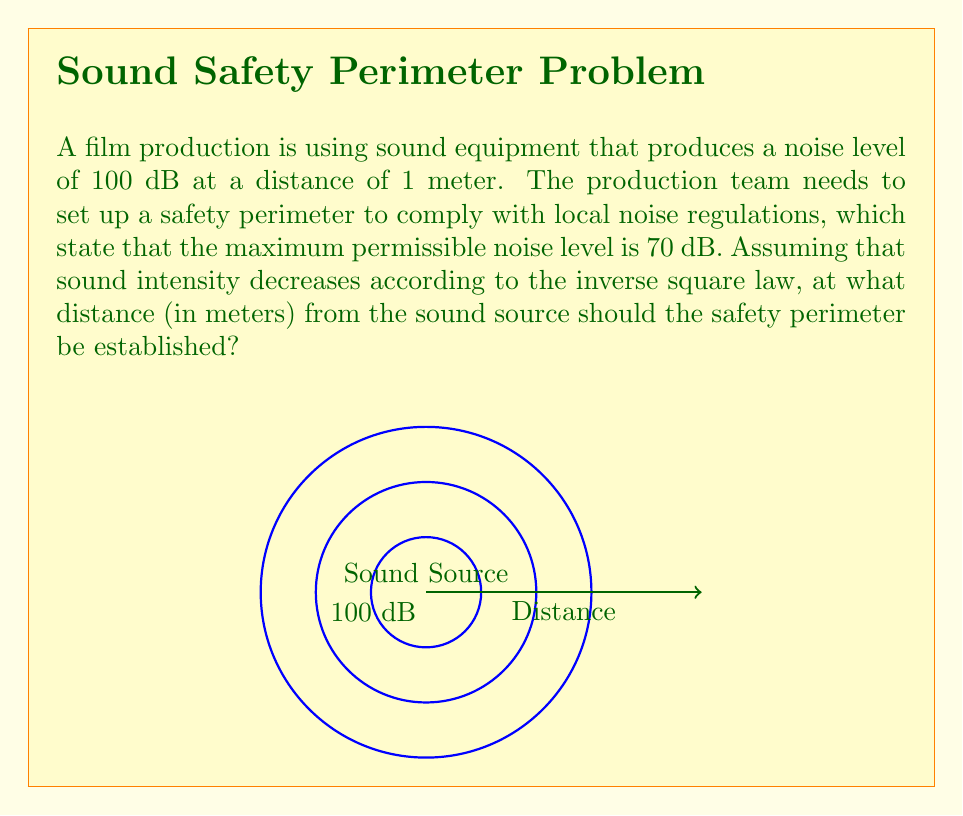Can you solve this math problem? To solve this problem, we'll use the inverse square law for sound intensity and the decibel scale. Let's break it down step-by-step:

1) The inverse square law states that sound intensity is inversely proportional to the square of the distance from the source. We can express this as:

   $$\frac{I_1}{I_2} = \frac{r_2^2}{r_1^2}$$

   where $I$ is intensity and $r$ is distance.

2) The decibel scale is logarithmic, defined as:

   $$dB = 10 \log_{10}(\frac{I}{I_0})$$

   where $I_0$ is a reference intensity.

3) We can relate the two distances and decibel levels:

   $$100 - 70 = 10 \log_{10}(\frac{r^2}{1^2})$$

   where $r$ is the distance we're looking for.

4) Simplify:

   $$30 = 10 \log_{10}(r^2)$$

5) Divide both sides by 10:

   $$3 = \log_{10}(r^2)$$

6) Take $10$ to the power of both sides:

   $$10^3 = r^2$$

7) Take the square root of both sides:

   $$r = \sqrt{1000} \approx 31.62$$

Therefore, the safety perimeter should be established at approximately 31.62 meters from the sound source.
Answer: 31.62 meters 